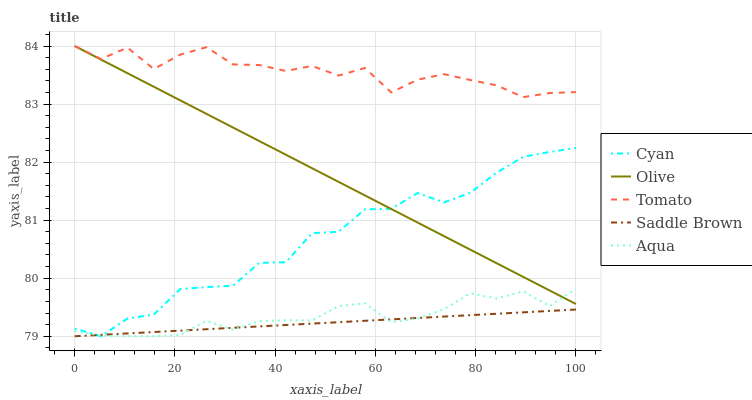Does Saddle Brown have the minimum area under the curve?
Answer yes or no. Yes. Does Tomato have the maximum area under the curve?
Answer yes or no. Yes. Does Cyan have the minimum area under the curve?
Answer yes or no. No. Does Cyan have the maximum area under the curve?
Answer yes or no. No. Is Olive the smoothest?
Answer yes or no. Yes. Is Cyan the roughest?
Answer yes or no. Yes. Is Tomato the smoothest?
Answer yes or no. No. Is Tomato the roughest?
Answer yes or no. No. Does Cyan have the lowest value?
Answer yes or no. Yes. Does Tomato have the lowest value?
Answer yes or no. No. Does Tomato have the highest value?
Answer yes or no. Yes. Does Cyan have the highest value?
Answer yes or no. No. Is Saddle Brown less than Tomato?
Answer yes or no. Yes. Is Tomato greater than Aqua?
Answer yes or no. Yes. Does Aqua intersect Saddle Brown?
Answer yes or no. Yes. Is Aqua less than Saddle Brown?
Answer yes or no. No. Is Aqua greater than Saddle Brown?
Answer yes or no. No. Does Saddle Brown intersect Tomato?
Answer yes or no. No. 